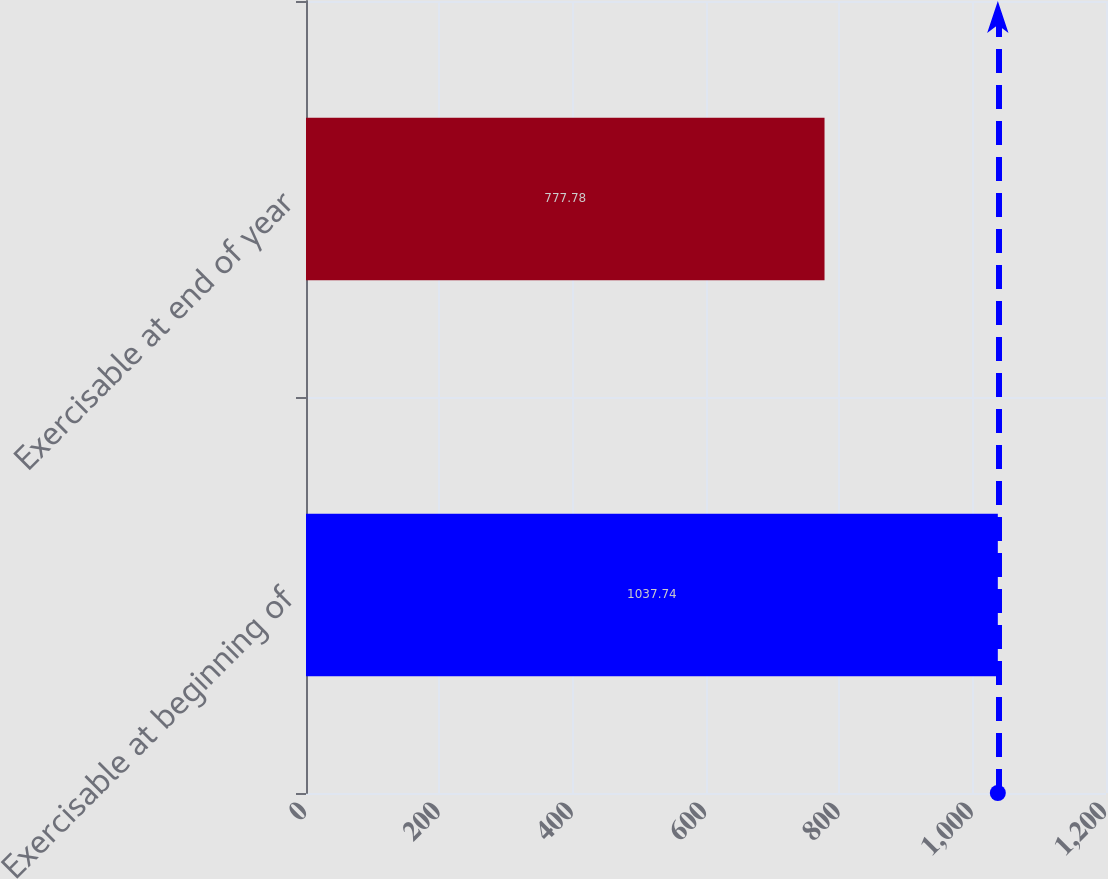Convert chart to OTSL. <chart><loc_0><loc_0><loc_500><loc_500><bar_chart><fcel>Exercisable at beginning of<fcel>Exercisable at end of year<nl><fcel>1037.74<fcel>777.78<nl></chart> 